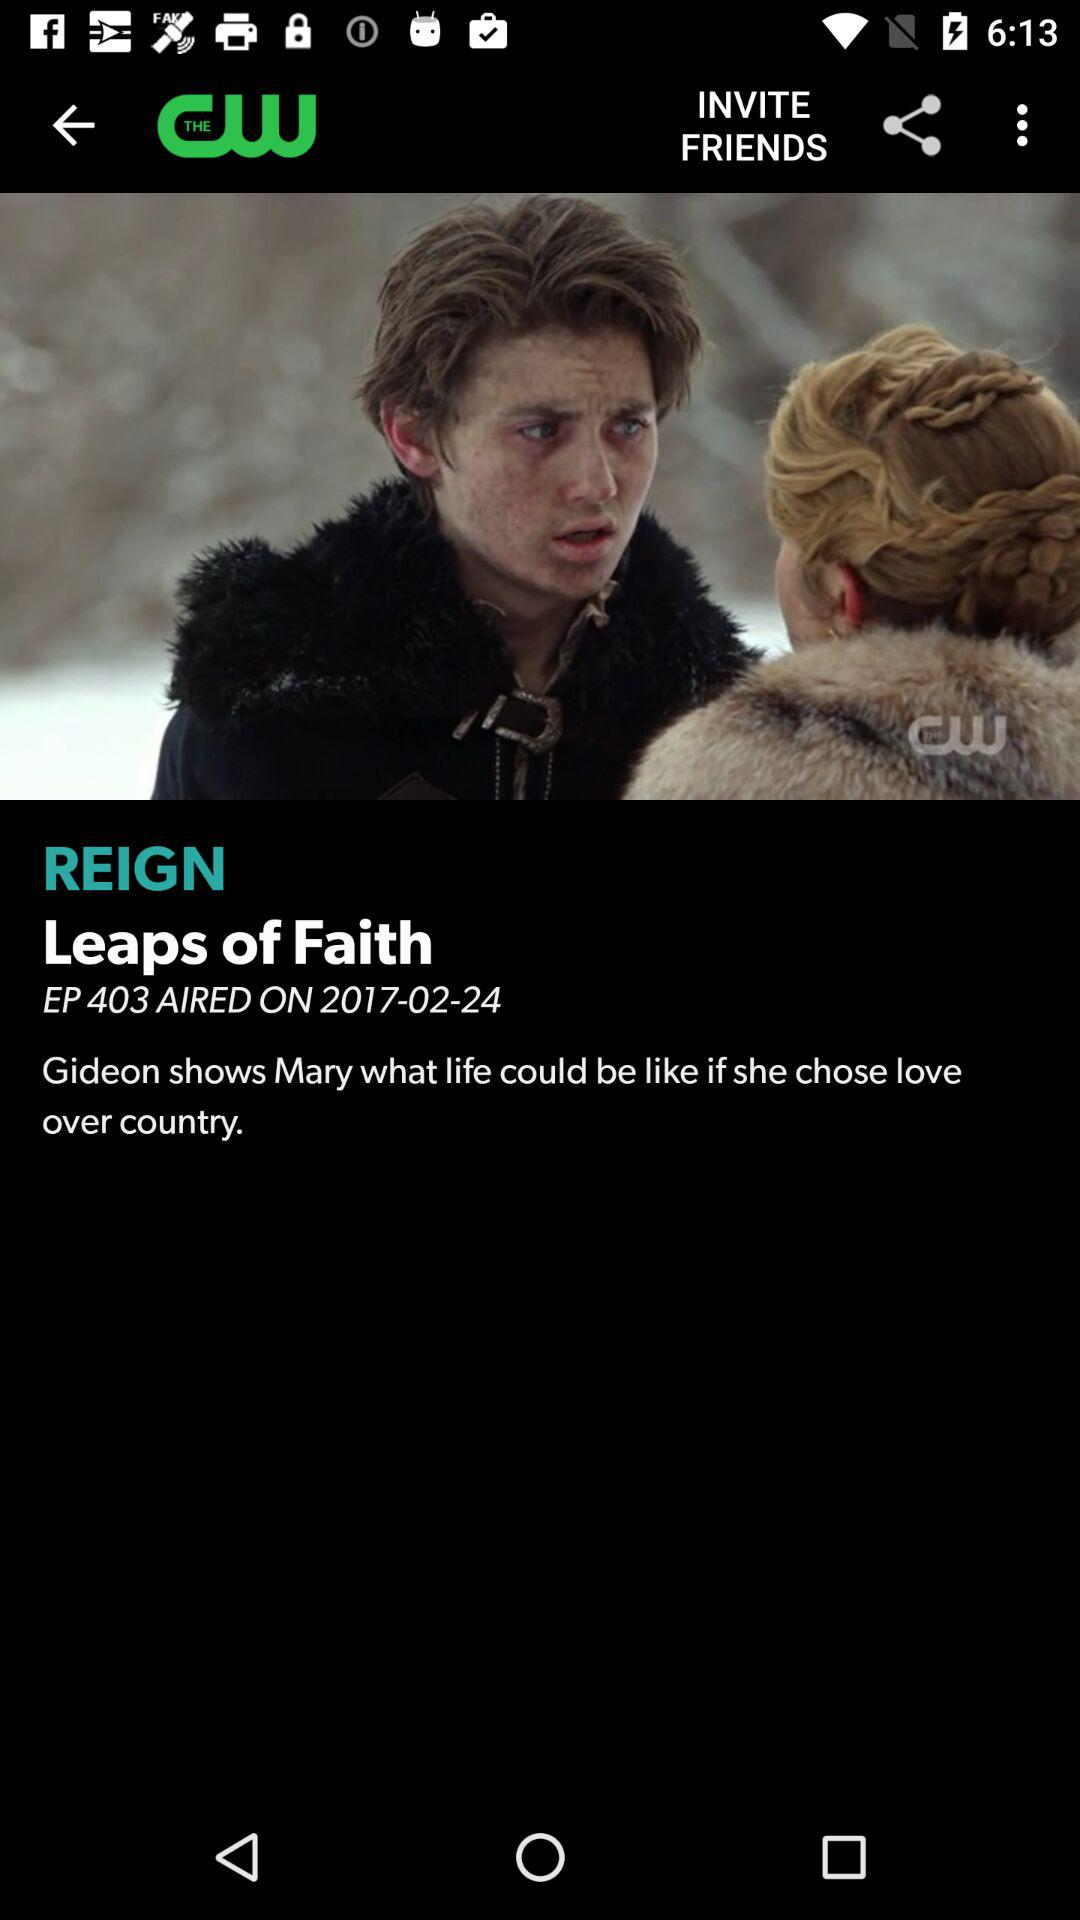What is the date? The date is February 24, 2017. 